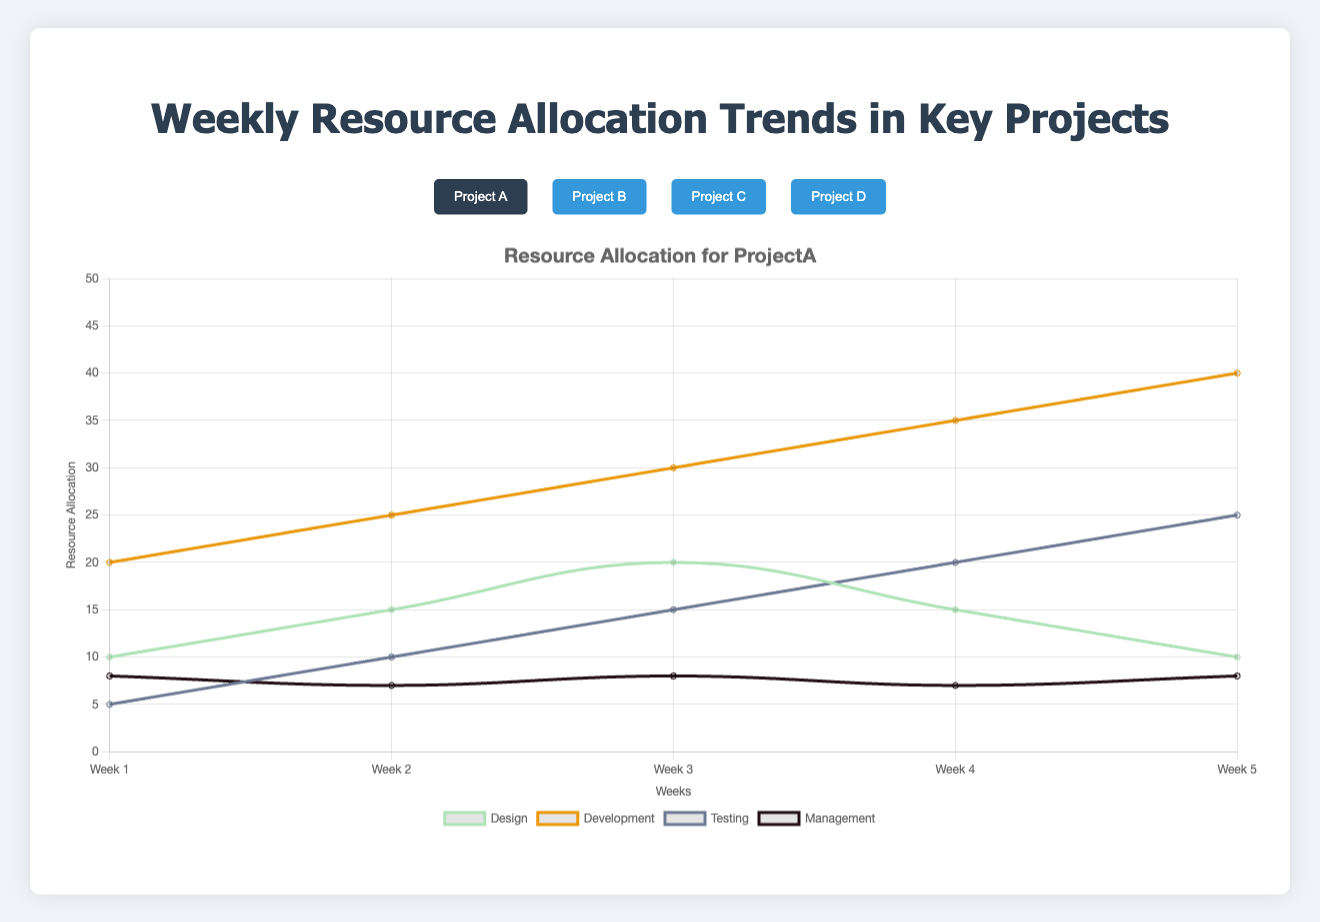What's the overall trend for Development resource allocation in Project A over the weeks? Looking at Project A, the Development resource allocation increases consistently from Week 1 (20) to Week 5 (40). The trend is upward.
Answer: Upward Which project has the highest resource allocation for Management in any week? Project B and Project C have the highest Management allocation at 10 in Week 5 for Project C and Week 3, 4, and 5 for Project B.
Answer: Project B, Project C By how much did the Testing resource allocation in Project A increase from Week 1 to Week 5? In Project A, Testing allocation starts at 5 in Week 1 and increases to 25 in Week 5. The increase is 25 - 5 = 20.
Answer: 20 In Project D, is the allocation for Development in Week 2 greater than Testing in Week 5? In Project D, Development in Week 2 is 25, and Testing in Week 5 is 25. Since they are equal, the development is not greater.
Answer: No What's the difference between the maximum resource allocation for Design across all projects? The maximum allocation for Design in Project A is 20 (Week 3) and in Project D is 25 (Week 5). The difference is 25 - 20 = 5.
Answer: 5 In Project C, what is the sum of the resources allocated for Management from Week 1 to Week 5? The Management allocations in Project C are [9, 9, 10, 10, 10]. Summing these gives 9 + 9 + 10 + 10 + 10 = 48.
Answer: 48 Which project shows the steepest increase in Development resources from Week 1 to Week 5? Steepness of increase can be measured by change over time. In Project A, Development increases from 20 to 40 (20 units); Project B from 10 to 35 (25 units); Project C from 25 to 25 (0 units); Project D from 20 to 40 (20 units). Project B has the steepest increase: 25 units.
Answer: Project B What is the overall trend for Planning resource allocation in Project C? In Project C, Planning allocation increases from 20 in Week 1 to 35 in Week 5. The trend is upward.
Answer: Upward 